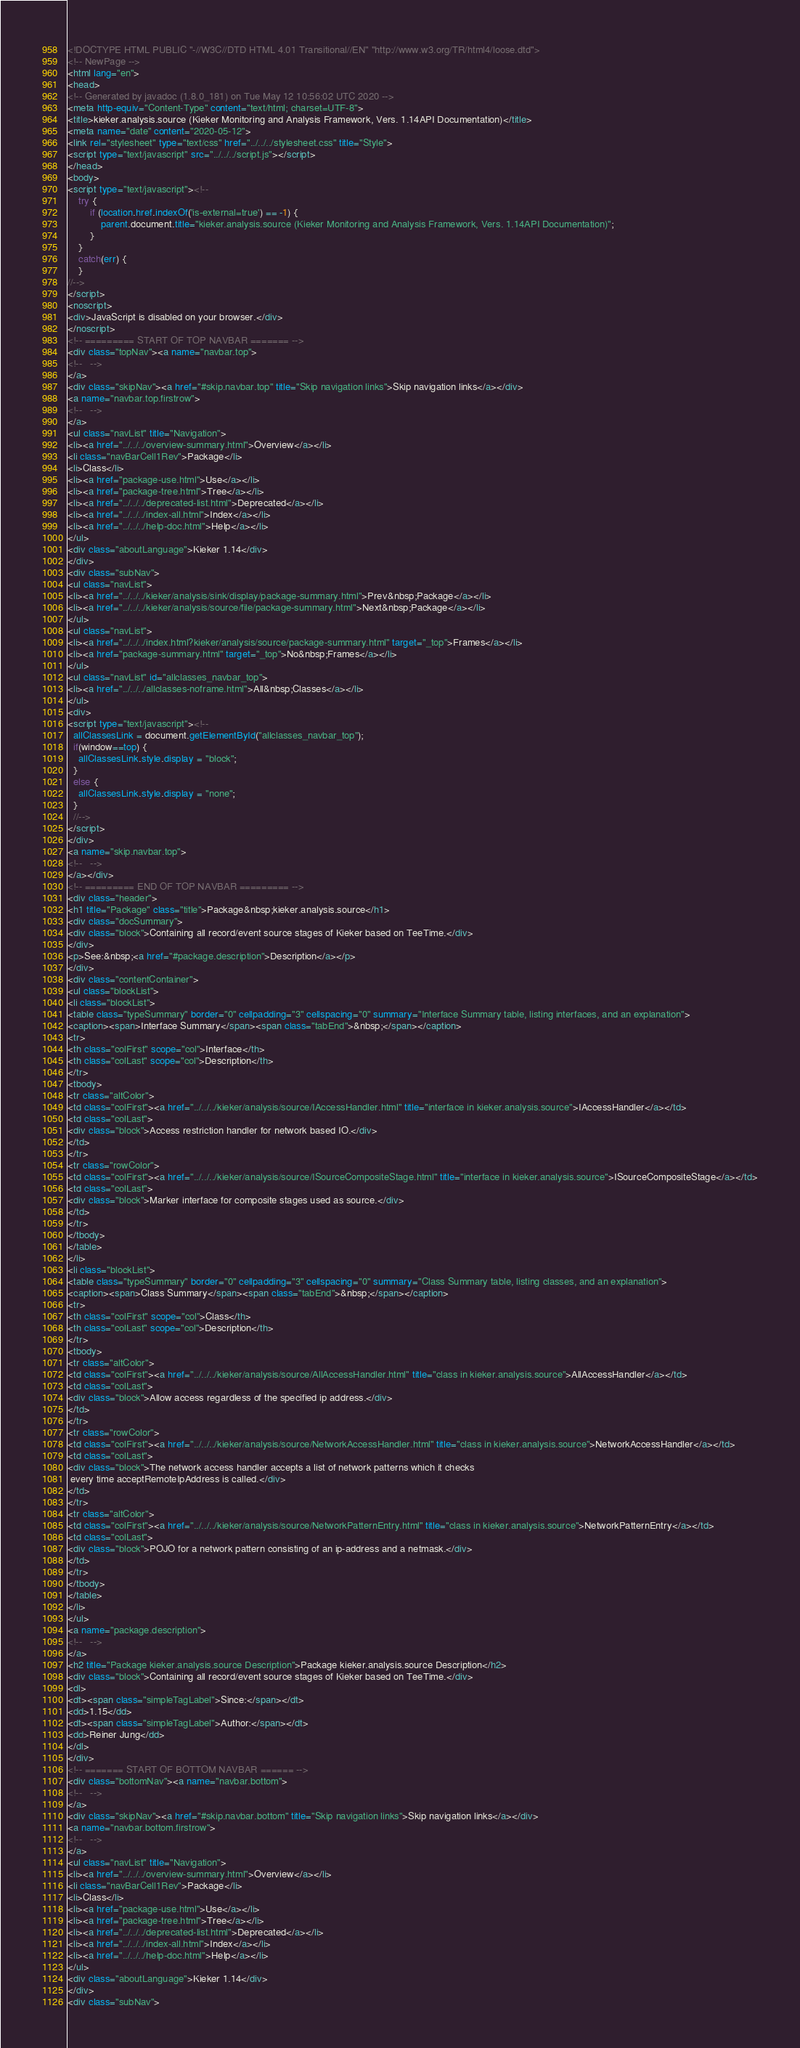Convert code to text. <code><loc_0><loc_0><loc_500><loc_500><_HTML_><!DOCTYPE HTML PUBLIC "-//W3C//DTD HTML 4.01 Transitional//EN" "http://www.w3.org/TR/html4/loose.dtd">
<!-- NewPage -->
<html lang="en">
<head>
<!-- Generated by javadoc (1.8.0_181) on Tue May 12 10:56:02 UTC 2020 -->
<meta http-equiv="Content-Type" content="text/html; charset=UTF-8">
<title>kieker.analysis.source (Kieker Monitoring and Analysis Framework, Vers. 1.14API Documentation)</title>
<meta name="date" content="2020-05-12">
<link rel="stylesheet" type="text/css" href="../../../stylesheet.css" title="Style">
<script type="text/javascript" src="../../../script.js"></script>
</head>
<body>
<script type="text/javascript"><!--
    try {
        if (location.href.indexOf('is-external=true') == -1) {
            parent.document.title="kieker.analysis.source (Kieker Monitoring and Analysis Framework, Vers. 1.14API Documentation)";
        }
    }
    catch(err) {
    }
//-->
</script>
<noscript>
<div>JavaScript is disabled on your browser.</div>
</noscript>
<!-- ========= START OF TOP NAVBAR ======= -->
<div class="topNav"><a name="navbar.top">
<!--   -->
</a>
<div class="skipNav"><a href="#skip.navbar.top" title="Skip navigation links">Skip navigation links</a></div>
<a name="navbar.top.firstrow">
<!--   -->
</a>
<ul class="navList" title="Navigation">
<li><a href="../../../overview-summary.html">Overview</a></li>
<li class="navBarCell1Rev">Package</li>
<li>Class</li>
<li><a href="package-use.html">Use</a></li>
<li><a href="package-tree.html">Tree</a></li>
<li><a href="../../../deprecated-list.html">Deprecated</a></li>
<li><a href="../../../index-all.html">Index</a></li>
<li><a href="../../../help-doc.html">Help</a></li>
</ul>
<div class="aboutLanguage">Kieker 1.14</div>
</div>
<div class="subNav">
<ul class="navList">
<li><a href="../../../kieker/analysis/sink/display/package-summary.html">Prev&nbsp;Package</a></li>
<li><a href="../../../kieker/analysis/source/file/package-summary.html">Next&nbsp;Package</a></li>
</ul>
<ul class="navList">
<li><a href="../../../index.html?kieker/analysis/source/package-summary.html" target="_top">Frames</a></li>
<li><a href="package-summary.html" target="_top">No&nbsp;Frames</a></li>
</ul>
<ul class="navList" id="allclasses_navbar_top">
<li><a href="../../../allclasses-noframe.html">All&nbsp;Classes</a></li>
</ul>
<div>
<script type="text/javascript"><!--
  allClassesLink = document.getElementById("allclasses_navbar_top");
  if(window==top) {
    allClassesLink.style.display = "block";
  }
  else {
    allClassesLink.style.display = "none";
  }
  //-->
</script>
</div>
<a name="skip.navbar.top">
<!--   -->
</a></div>
<!-- ========= END OF TOP NAVBAR ========= -->
<div class="header">
<h1 title="Package" class="title">Package&nbsp;kieker.analysis.source</h1>
<div class="docSummary">
<div class="block">Containing all record/event source stages of Kieker based on TeeTime.</div>
</div>
<p>See:&nbsp;<a href="#package.description">Description</a></p>
</div>
<div class="contentContainer">
<ul class="blockList">
<li class="blockList">
<table class="typeSummary" border="0" cellpadding="3" cellspacing="0" summary="Interface Summary table, listing interfaces, and an explanation">
<caption><span>Interface Summary</span><span class="tabEnd">&nbsp;</span></caption>
<tr>
<th class="colFirst" scope="col">Interface</th>
<th class="colLast" scope="col">Description</th>
</tr>
<tbody>
<tr class="altColor">
<td class="colFirst"><a href="../../../kieker/analysis/source/IAccessHandler.html" title="interface in kieker.analysis.source">IAccessHandler</a></td>
<td class="colLast">
<div class="block">Access restriction handler for network based IO.</div>
</td>
</tr>
<tr class="rowColor">
<td class="colFirst"><a href="../../../kieker/analysis/source/ISourceCompositeStage.html" title="interface in kieker.analysis.source">ISourceCompositeStage</a></td>
<td class="colLast">
<div class="block">Marker interface for composite stages used as source.</div>
</td>
</tr>
</tbody>
</table>
</li>
<li class="blockList">
<table class="typeSummary" border="0" cellpadding="3" cellspacing="0" summary="Class Summary table, listing classes, and an explanation">
<caption><span>Class Summary</span><span class="tabEnd">&nbsp;</span></caption>
<tr>
<th class="colFirst" scope="col">Class</th>
<th class="colLast" scope="col">Description</th>
</tr>
<tbody>
<tr class="altColor">
<td class="colFirst"><a href="../../../kieker/analysis/source/AllAccessHandler.html" title="class in kieker.analysis.source">AllAccessHandler</a></td>
<td class="colLast">
<div class="block">Allow access regardless of the specified ip address.</div>
</td>
</tr>
<tr class="rowColor">
<td class="colFirst"><a href="../../../kieker/analysis/source/NetworkAccessHandler.html" title="class in kieker.analysis.source">NetworkAccessHandler</a></td>
<td class="colLast">
<div class="block">The network access handler accepts a list of network patterns which it checks
 every time acceptRemoteIpAddress is called.</div>
</td>
</tr>
<tr class="altColor">
<td class="colFirst"><a href="../../../kieker/analysis/source/NetworkPatternEntry.html" title="class in kieker.analysis.source">NetworkPatternEntry</a></td>
<td class="colLast">
<div class="block">POJO for a network pattern consisting of an ip-address and a netmask.</div>
</td>
</tr>
</tbody>
</table>
</li>
</ul>
<a name="package.description">
<!--   -->
</a>
<h2 title="Package kieker.analysis.source Description">Package kieker.analysis.source Description</h2>
<div class="block">Containing all record/event source stages of Kieker based on TeeTime.</div>
<dl>
<dt><span class="simpleTagLabel">Since:</span></dt>
<dd>1.15</dd>
<dt><span class="simpleTagLabel">Author:</span></dt>
<dd>Reiner Jung</dd>
</dl>
</div>
<!-- ======= START OF BOTTOM NAVBAR ====== -->
<div class="bottomNav"><a name="navbar.bottom">
<!--   -->
</a>
<div class="skipNav"><a href="#skip.navbar.bottom" title="Skip navigation links">Skip navigation links</a></div>
<a name="navbar.bottom.firstrow">
<!--   -->
</a>
<ul class="navList" title="Navigation">
<li><a href="../../../overview-summary.html">Overview</a></li>
<li class="navBarCell1Rev">Package</li>
<li>Class</li>
<li><a href="package-use.html">Use</a></li>
<li><a href="package-tree.html">Tree</a></li>
<li><a href="../../../deprecated-list.html">Deprecated</a></li>
<li><a href="../../../index-all.html">Index</a></li>
<li><a href="../../../help-doc.html">Help</a></li>
</ul>
<div class="aboutLanguage">Kieker 1.14</div>
</div>
<div class="subNav"></code> 